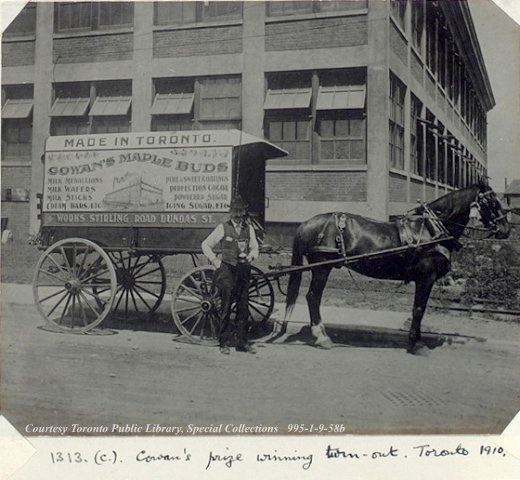Describe the objects in this image and their specific colors. I can see horse in ivory, black, and gray tones and people in ivory, black, gray, and darkgray tones in this image. 